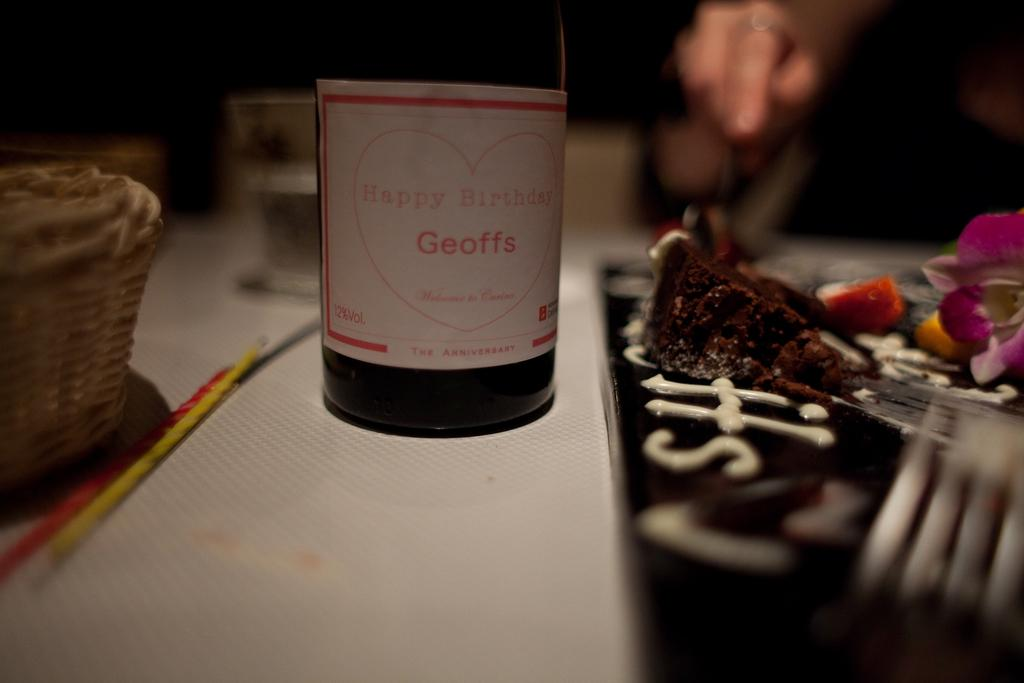<image>
Write a terse but informative summary of the picture. A bottle with a label on it that reads Happy Birthday Geoffs. 